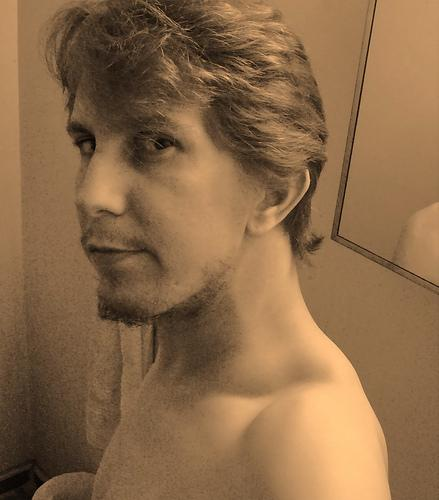Write a detailed description of the man's face in the image. In the image, the man has short wavy hair, a thin sparse mustache, scraggly beard on his chin, and is looking directly at the camera. Give a concise description of the main subject of the image and their surroundings. A shirtless man with facial hair takes a selfie, surrounded by a mirror, towel, and shower curtain in the bathroom. Identify the main focus of the image and describe the person's appearance. The image features a man with short wavy hair, facial hair, and no shirt on. He appears to be taking a selfie in a bathroom setting. Narrate the image from the perspective of the man in the picture. Standing shirtless in my bathroom domain, I pause to snap a selfie, a reflection of my visage framed by mirror, towel, and curtain. Highlight the primary activity in the image and describe the visible elements. A man is taking a selfie in the bathroom, with a mirror, towel, and shower curtain visible around him. Mention the key elements in the image and their position. The image presents a shirtless man standing in a bathroom, a mirror on the bathroom wall, a towel hanging on the wall, and a shower curtain behind the man. Provide a brief overview of the scene captured in the image. A shirtless man with facial hair is taking a selfie in the bathroom, surrounded by a mirror, a towel hanging on the wall, and a shower curtain. Using an informal language style, describe what's happening in the image. A dude without a shirt, rocking some facial hair, is taking a selfie in the bathroom, with a mirror, towel, and shower curtain hanging around. Using a poetic language style, describe the man in the image and what he is doing. Amidst reflective glass and draped linens, a bare-chested soul gazes upon the lens, capturing his essence in a solitary selfie. 